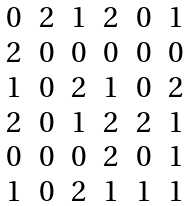<formula> <loc_0><loc_0><loc_500><loc_500>\begin{matrix} 0 & 2 & 1 & 2 & 0 & 1 \\ 2 & 0 & 0 & 0 & 0 & 0 \\ 1 & 0 & 2 & 1 & 0 & 2 \\ 2 & 0 & 1 & 2 & 2 & 1 \\ 0 & 0 & 0 & 2 & 0 & 1 \\ 1 & 0 & 2 & 1 & 1 & 1 \end{matrix}</formula> 